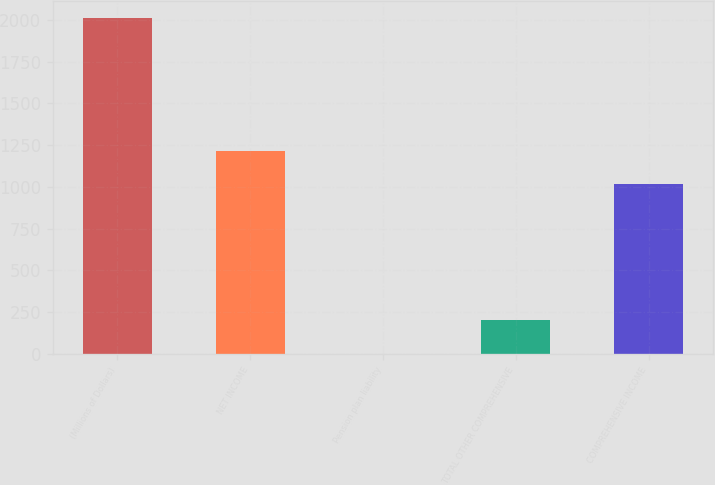Convert chart. <chart><loc_0><loc_0><loc_500><loc_500><bar_chart><fcel>(Millions of Dollars)<fcel>NET INCOME<fcel>Pension plan liability<fcel>TOTAL OTHER COMPREHENSIVE<fcel>COMPREHENSIVE INCOME<nl><fcel>2012<fcel>1217.1<fcel>1<fcel>202.1<fcel>1016<nl></chart> 